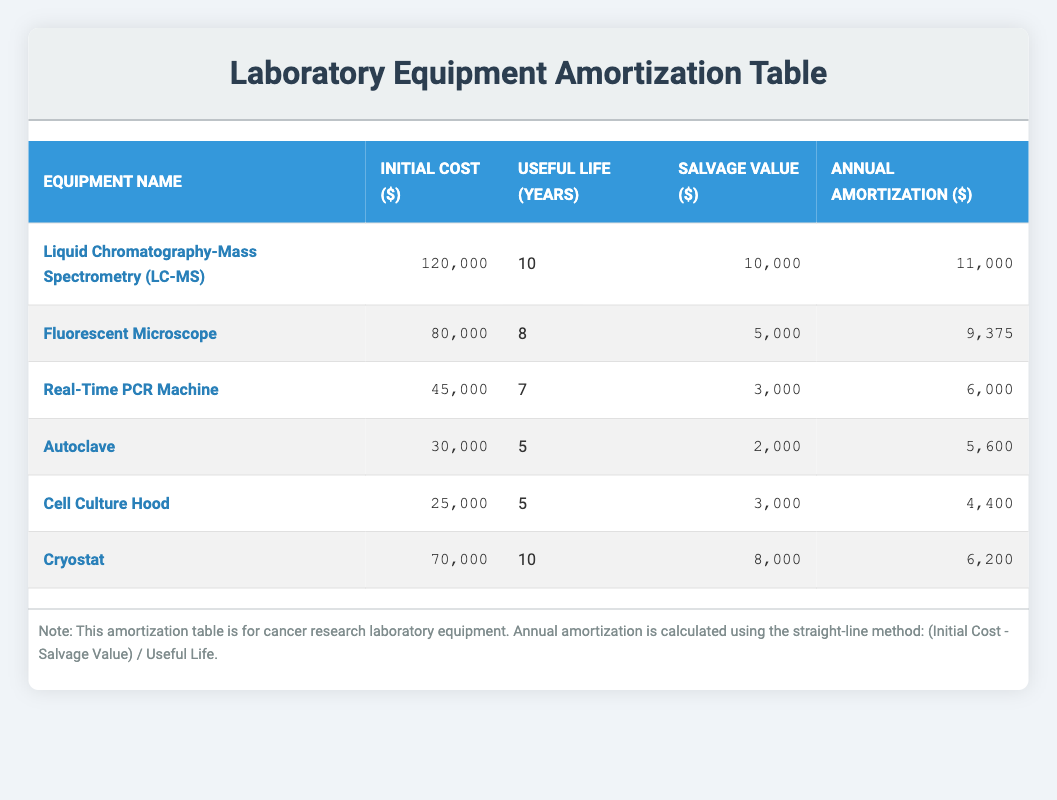What is the initial cost of the Cryostat? The table lists the initial cost of the Cryostat, which is directly provided in the 'Initial Cost ($)' column. The value is 70000.
Answer: 70000 How many years of useful life does the Fluorescent Microscope have? In the 'Useful Life (Years)' column of the table, the useful life of the Fluorescent Microscope is specified as 8 years.
Answer: 8 What is the total annual amortization for all equipment combined? To calculate the total annual amortization, sum up the values in the 'Annual Amortization ($)' column: 11000 + 9375 + 6000 + 5600 + 4400 + 6200 = 40000.
Answer: 40000 Does the Real-Time PCR Machine have a salvage value greater than 3000? Referencing the 'Salvage Value ($)' column, the salvage value of the Real-Time PCR Machine is listed as 3000. Since it is not greater than 3000, the answer is false.
Answer: No What is the average annual amortization across all pieces of equipment? First, calculate the total annual amortization as previously calculated (40000). There are 6 pieces of equipment, so the average is 40000 divided by 6, which equals approximately 6666.67.
Answer: 6666.67 Which equipment has the highest annual amortization? By examining the 'Annual Amortization ($)' column, Liquid Chromatography-Mass Spectrometry has the highest value at 11000, which is greater than all others.
Answer: Liquid Chromatography-Mass Spectrometry What is the total initial cost for equipment with a useful life of 5 years? Identify the equipment with a useful life of 5 years from the 'Useful Life (Years)' column. There are two pieces: Autoclave (30000) and Cell Culture Hood (25000). Adding these gives a total initial cost of 30000 + 25000 = 55000.
Answer: 55000 Is the Liquid Chromatography-Mass Spectrometry equipment older than 8 years? The useful life of Liquid Chromatography-Mass Spectrometry is listed as 10 years. Since 10 years is greater than 8, the statement is true.
Answer: Yes 